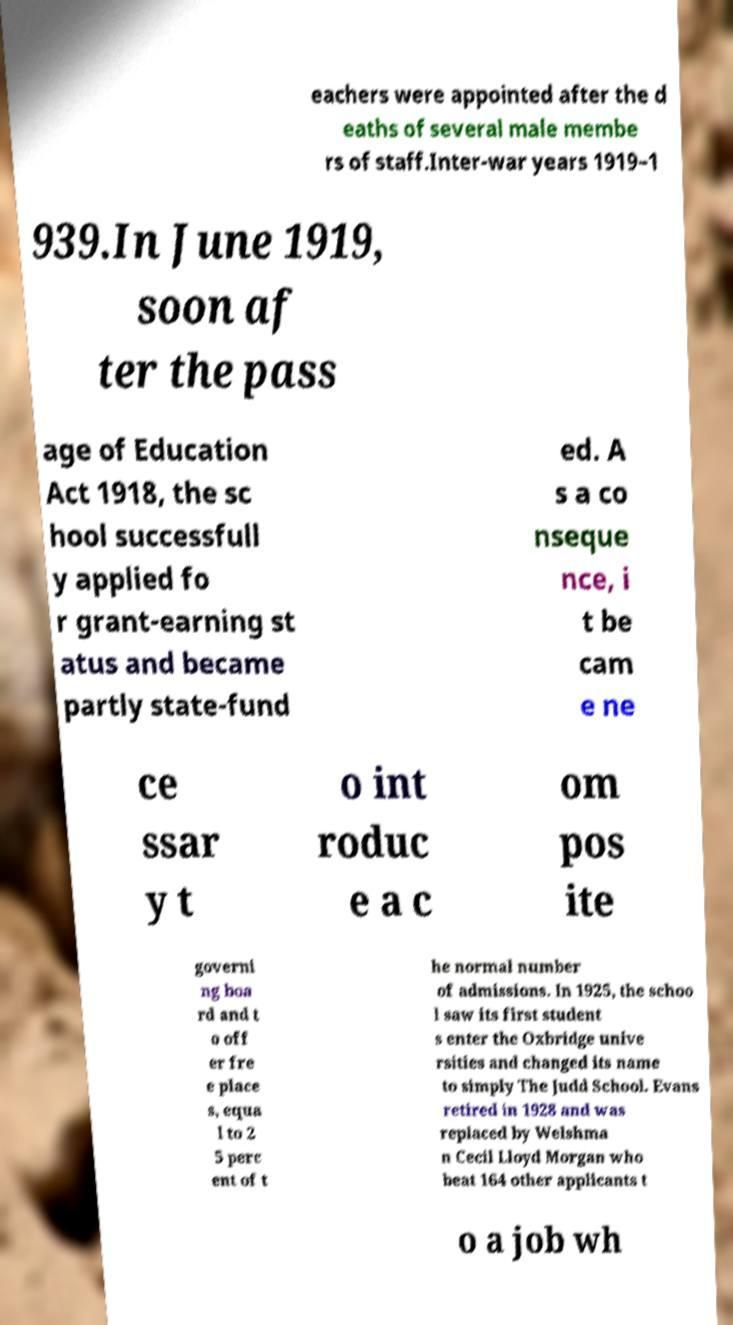Can you read and provide the text displayed in the image?This photo seems to have some interesting text. Can you extract and type it out for me? eachers were appointed after the d eaths of several male membe rs of staff.Inter-war years 1919–1 939.In June 1919, soon af ter the pass age of Education Act 1918, the sc hool successfull y applied fo r grant-earning st atus and became partly state-fund ed. A s a co nseque nce, i t be cam e ne ce ssar y t o int roduc e a c om pos ite governi ng boa rd and t o off er fre e place s, equa l to 2 5 perc ent of t he normal number of admissions. In 1925, the schoo l saw its first student s enter the Oxbridge unive rsities and changed its name to simply The Judd School. Evans retired in 1928 and was replaced by Welshma n Cecil Lloyd Morgan who beat 164 other applicants t o a job wh 